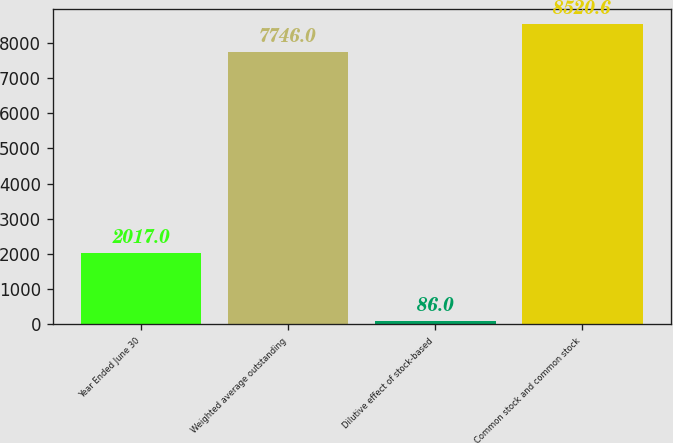Convert chart. <chart><loc_0><loc_0><loc_500><loc_500><bar_chart><fcel>Year Ended June 30<fcel>Weighted average outstanding<fcel>Dilutive effect of stock-based<fcel>Common stock and common stock<nl><fcel>2017<fcel>7746<fcel>86<fcel>8520.6<nl></chart> 